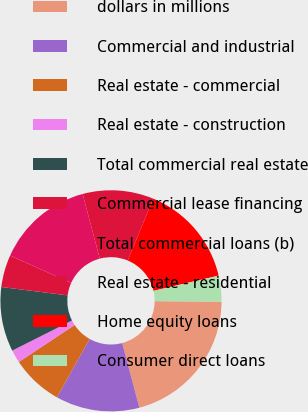<chart> <loc_0><loc_0><loc_500><loc_500><pie_chart><fcel>dollars in millions<fcel>Commercial and industrial<fcel>Real estate - commercial<fcel>Real estate - construction<fcel>Total commercial real estate<fcel>Commercial lease financing<fcel>Total commercial loans (b)<fcel>Real estate - residential<fcel>Home equity loans<fcel>Consumer direct loans<nl><fcel>20.75%<fcel>12.26%<fcel>7.55%<fcel>1.89%<fcel>9.43%<fcel>4.72%<fcel>14.15%<fcel>10.38%<fcel>15.09%<fcel>3.78%<nl></chart> 